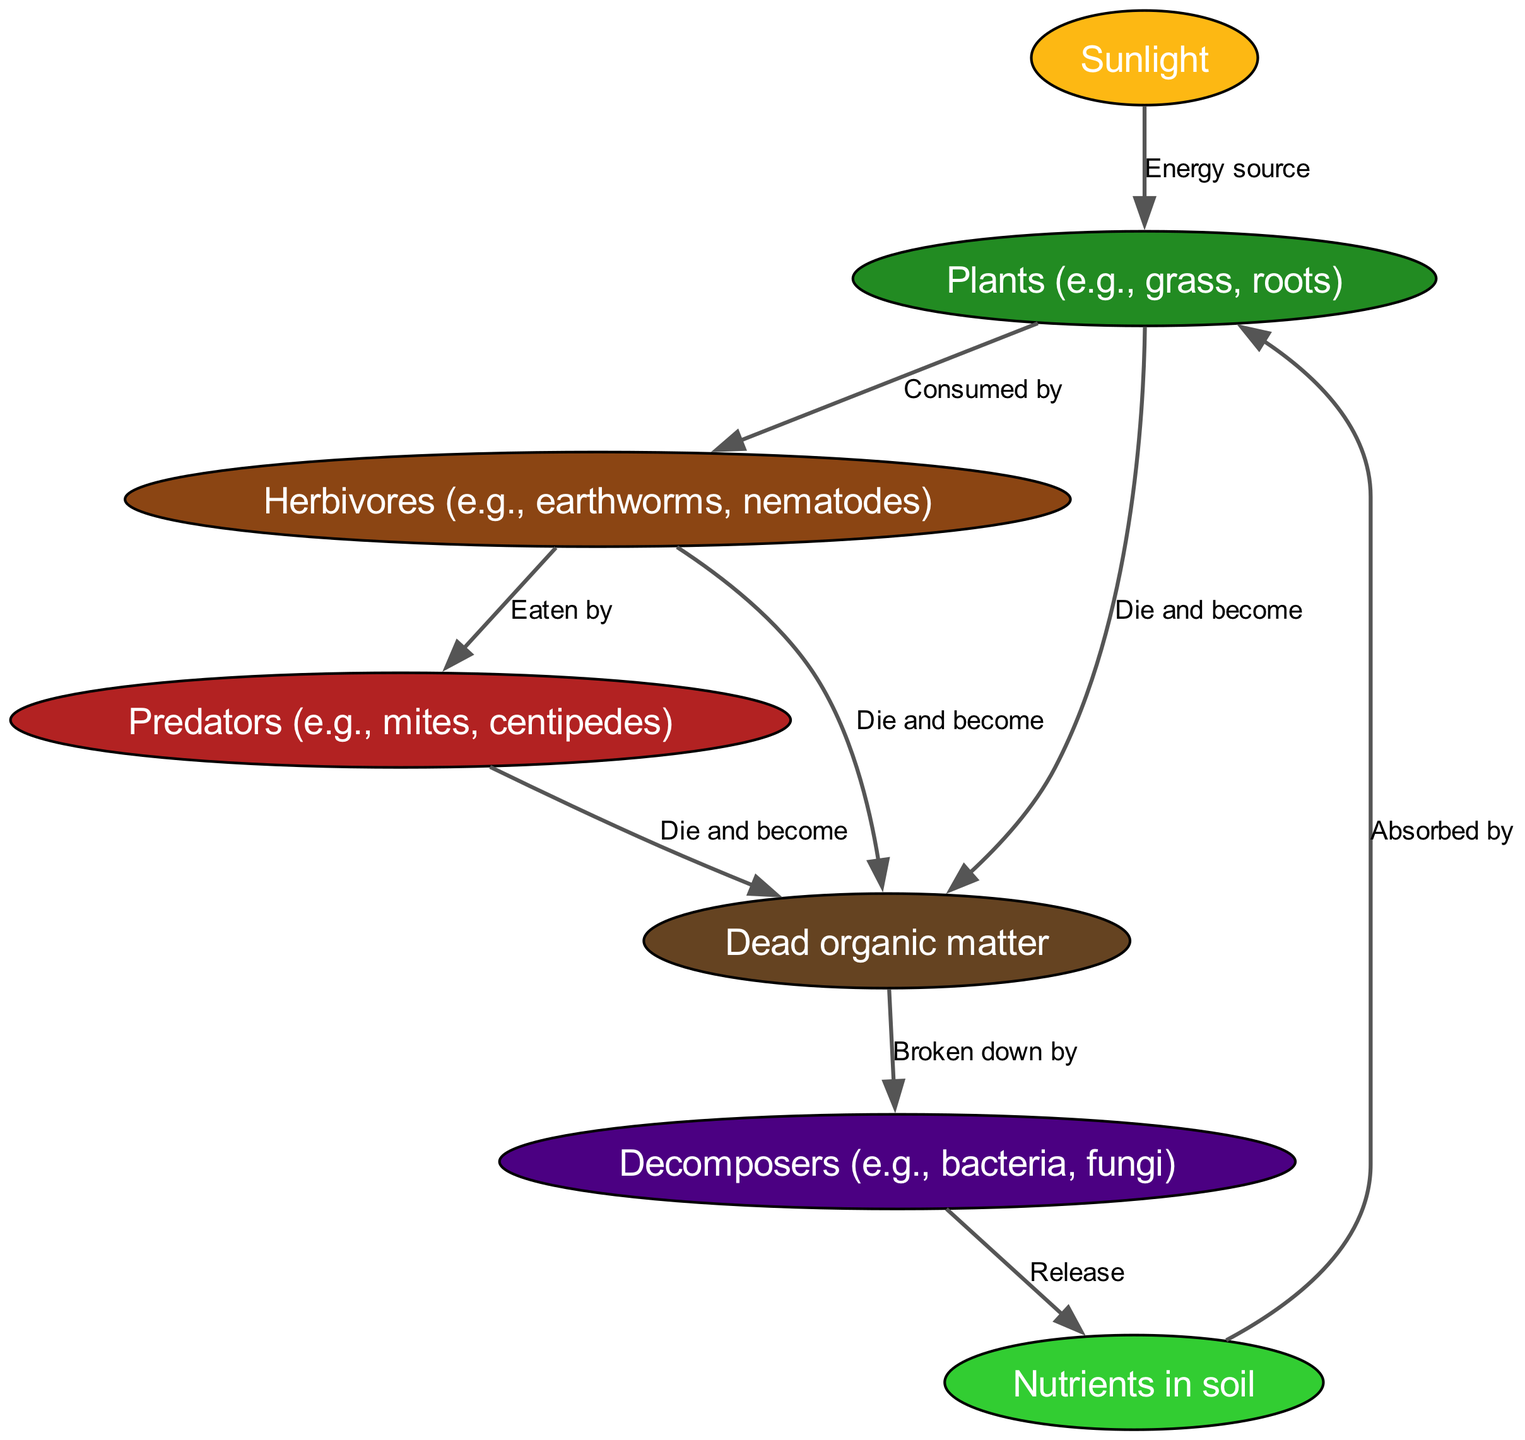What is the energy source for plants? The diagram indicates that sunlight is the energy source for plants, as it has a direct edge labeled "Energy source" pointing from sunlight to plants.
Answer: Sunlight How many nodes are present in the diagram? The diagram contains seven nodes: sunlight, plants, herbivores, predators, decomposers, organic matter, and nutrients. Therefore, counting each unique node, we find the total is seven.
Answer: 7 Who is eaten by predators? According to the diagram, herbivores are identified as the group that is eaten by predators, shown by the edge labeled "Eaten by" pointing from herbivores to predators.
Answer: Herbivores What do decomposers release? The edge labeled "Release" going from decomposers to nutrients indicates that decomposers play a crucial role in the food chain by releasing nutrients.
Answer: Nutrients What happens to organic matter? Organic matter undergoes decomposition by various organisms, as indicated in the diagram where there are multiple edges directed from plants, herbivores, and predators to organic matter labeled "Die and become". This implies that organic matter is the result of the death of these organisms.
Answer: Broken down by decomposers What role do nutrients play in the food chain? Nutrients are absorbed by plants, as depicted by the edge from nutrients to plants labeled "Absorbed by", illustrating the vital role nutrients play in supporting plant life, which is foundational in the food chain.
Answer: Absorbed by plants How many edges are there in the diagram? By examining the diagram, we can count the edges that connect the nodes. There are nine edges connecting the various nodes in the food chain.
Answer: 9 What do dead organic matter become? The diagram specifies through edges with the label "Broken down by" that dead organic matter is processed by decomposers, highlighting their essential role in recycling nutrients within the ecosystem.
Answer: Nutrients 